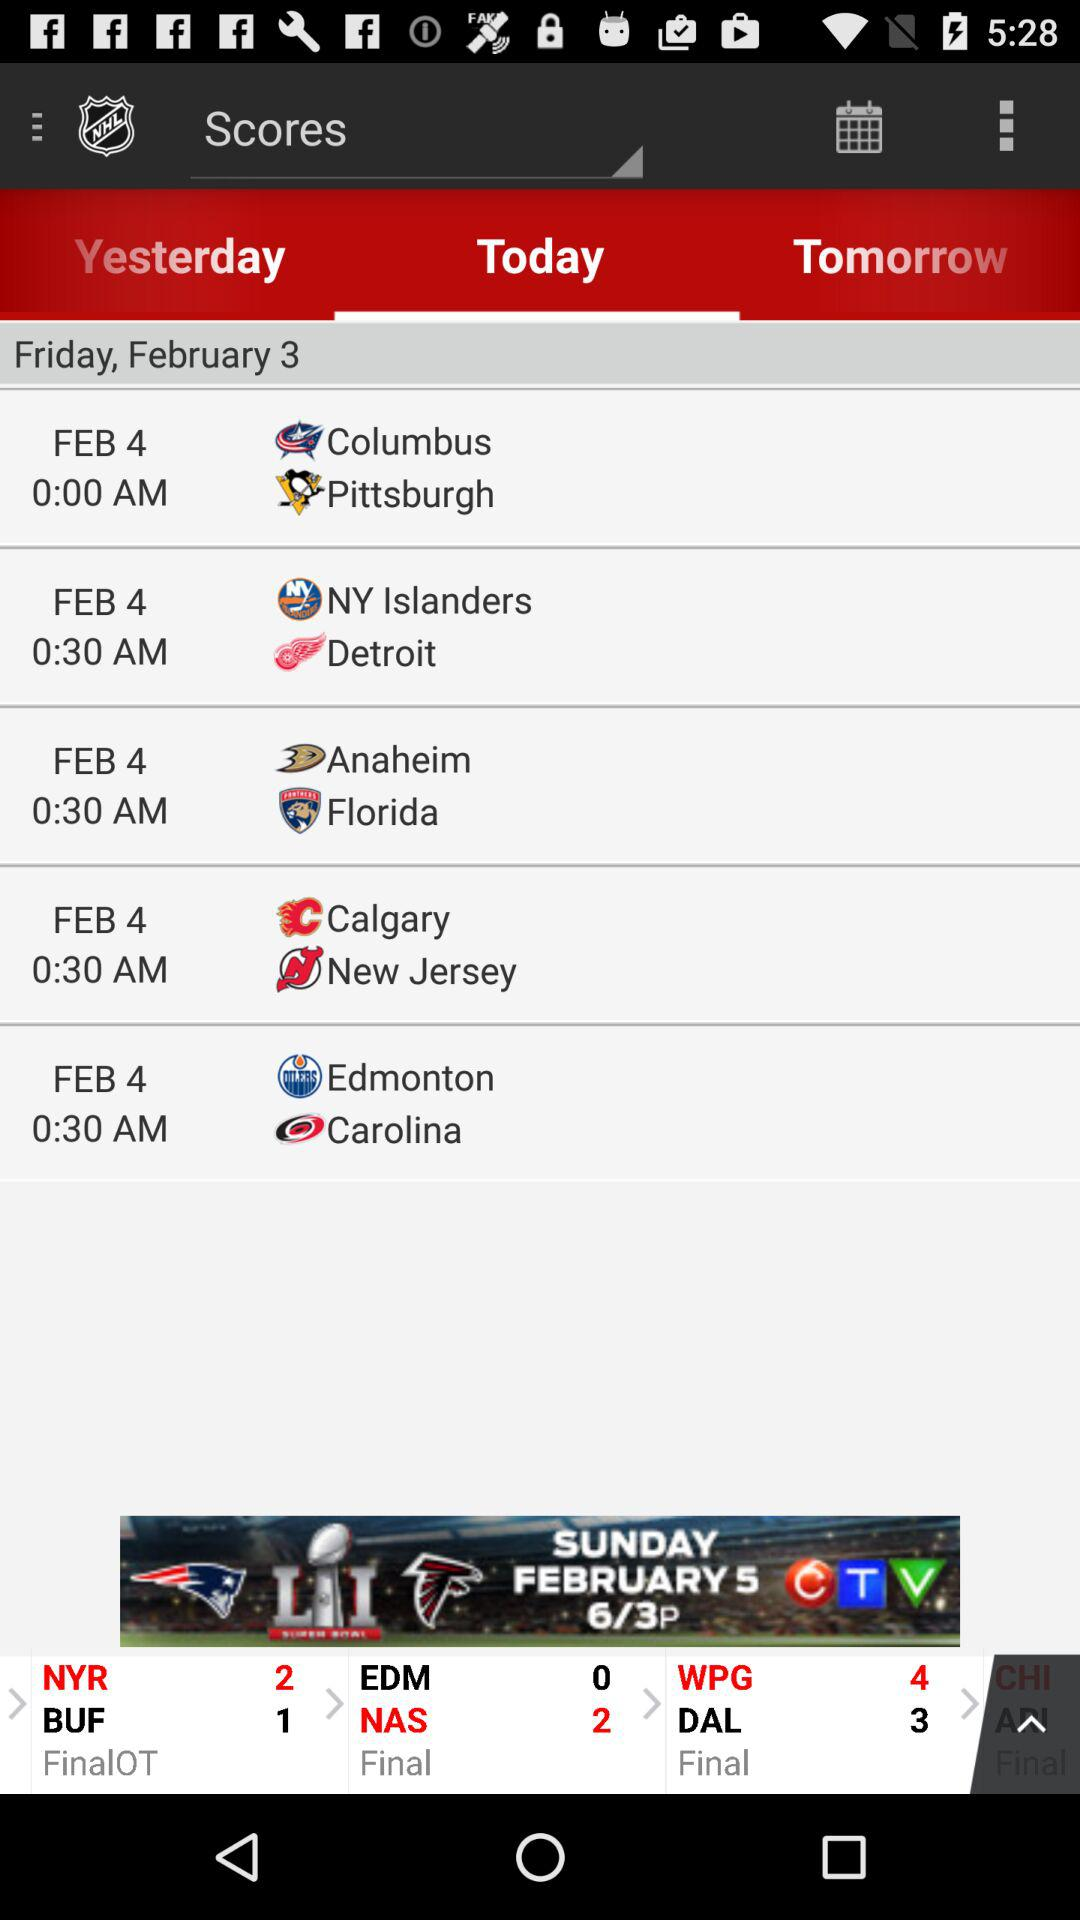What is the selected tab? The selected tab is "Today". 